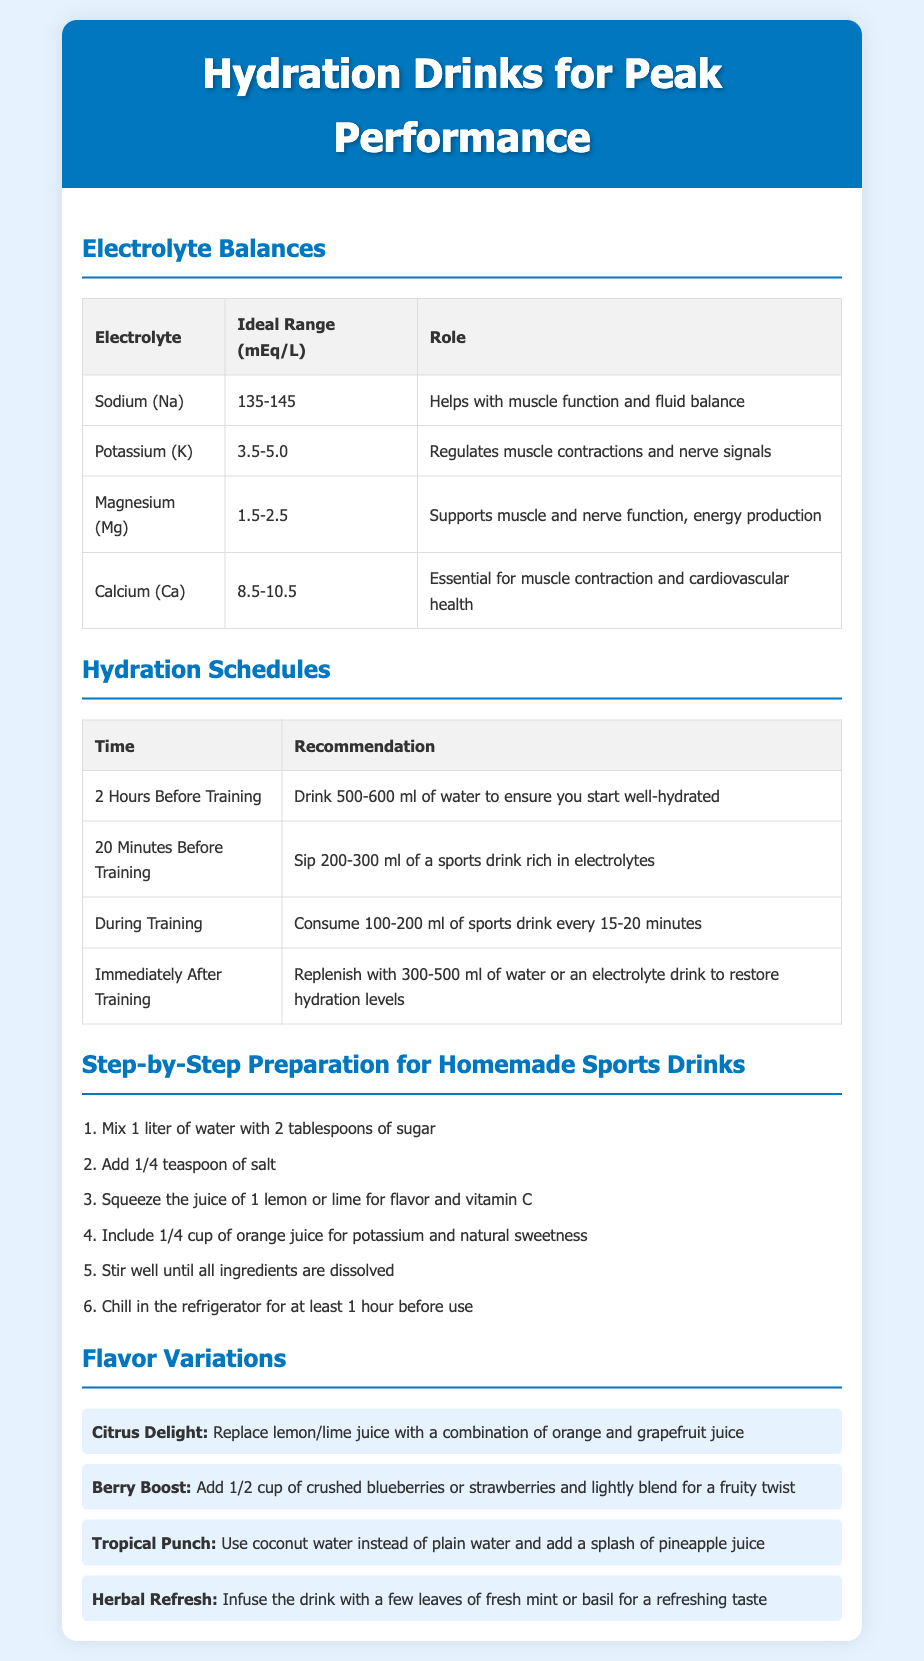what is the ideal range for Sodium? The ideal range for Sodium is provided in the table, which is 135-145 mEq/L.
Answer: 135-145 mEq/L what is the recommendation for hydration two hours before training? The table outlines that the recommendation is to drink 500-600 ml of water.
Answer: 500-600 ml how many tablespoons of sugar are needed for the homemade sports drink? The preparation steps indicate that 2 tablespoons of sugar are required.
Answer: 2 tablespoons what ingredient can be added for a fruity twist? The flavor variations mention adding crushed blueberries or strawberries for a fruity twist.
Answer: crushed blueberries or strawberries what is the role of Potassium in electrolyte balance? The table lists that Potassium regulates muscle contractions and nerve signals.
Answer: Regulates muscle contractions and nerve signals what is the first step in preparing a homemade sports drink? The step-by-step preparation begins with mixing 1 liter of water with 2 tablespoons of sugar.
Answer: Mix 1 liter of water with 2 tablespoons of sugar which flavor variation uses coconut water? The flavor variations mention the Tropical Punch as the one that uses coconut water.
Answer: Tropical Punch how much sports drink should be consumed during training? The hydration schedule states that 100-200 ml of sports drink should be consumed every 15-20 minutes.
Answer: 100-200 ml every 15-20 minutes 